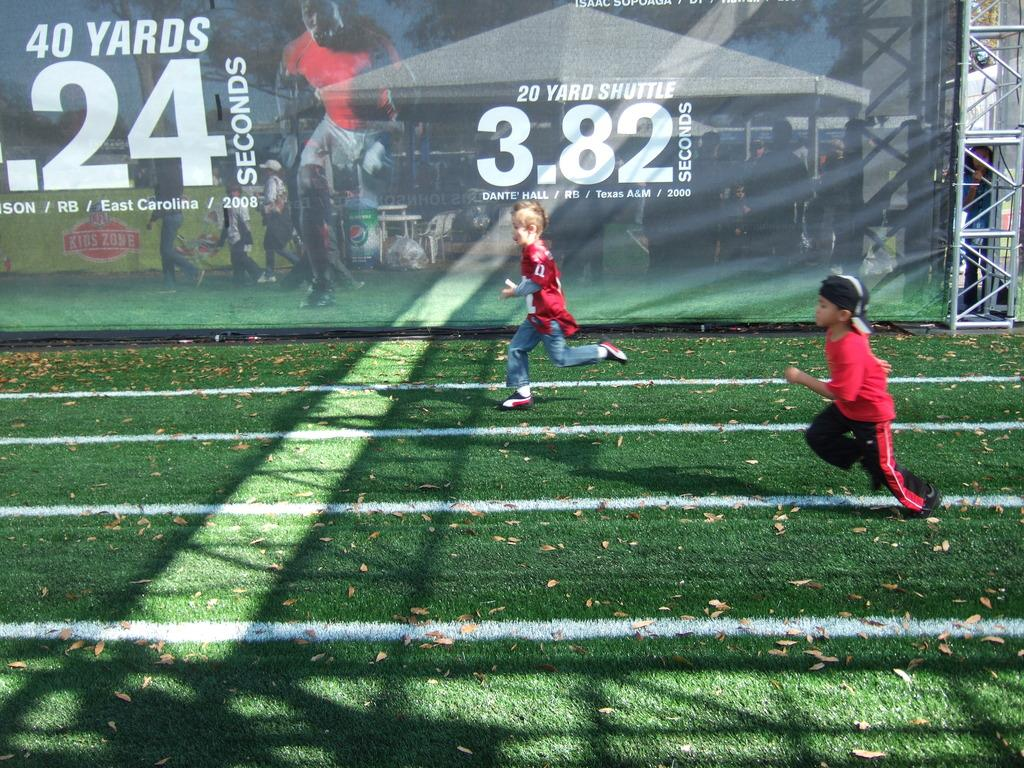<image>
Provide a brief description of the given image. Two boys having a race with the numbers 3.82 behind them. 